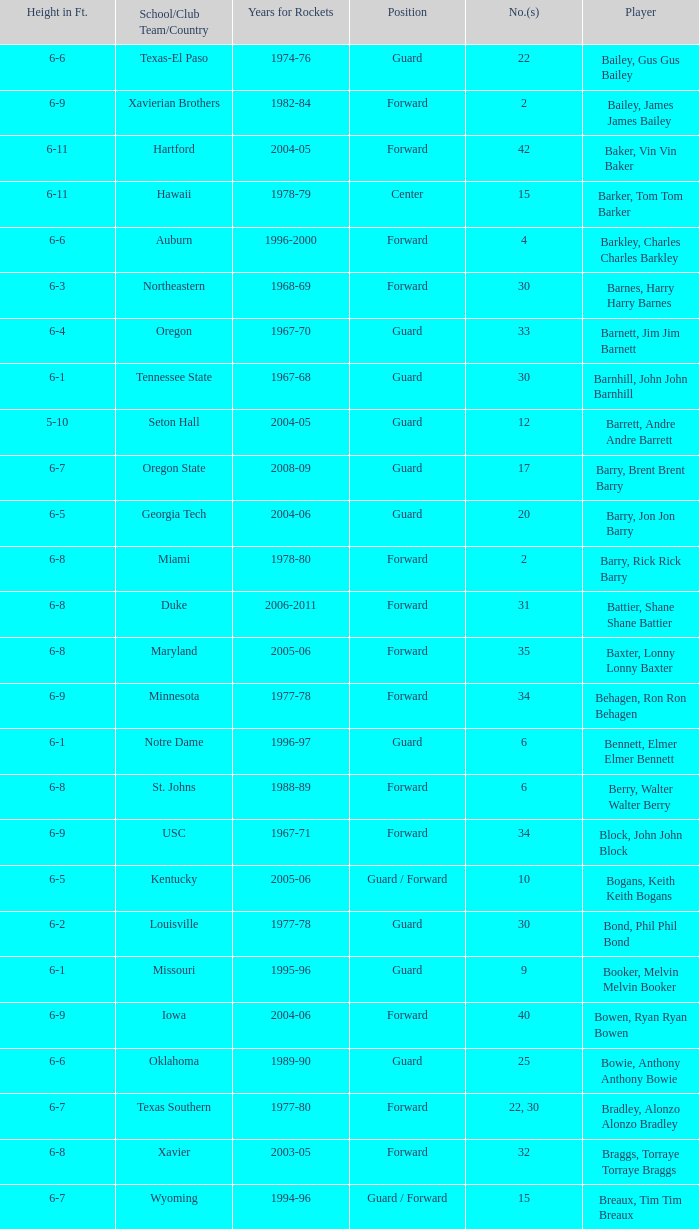What position is number 35 whose height is 6-6? Forward. 